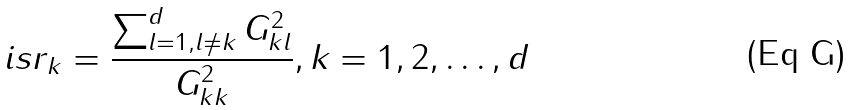Convert formula to latex. <formula><loc_0><loc_0><loc_500><loc_500>i s r _ { k } = \frac { \sum ^ { d } _ { l = 1 , l \neq k } G ^ { 2 } _ { k l } } { G ^ { 2 } _ { k k } } , k = 1 , 2 , \dots , d</formula> 